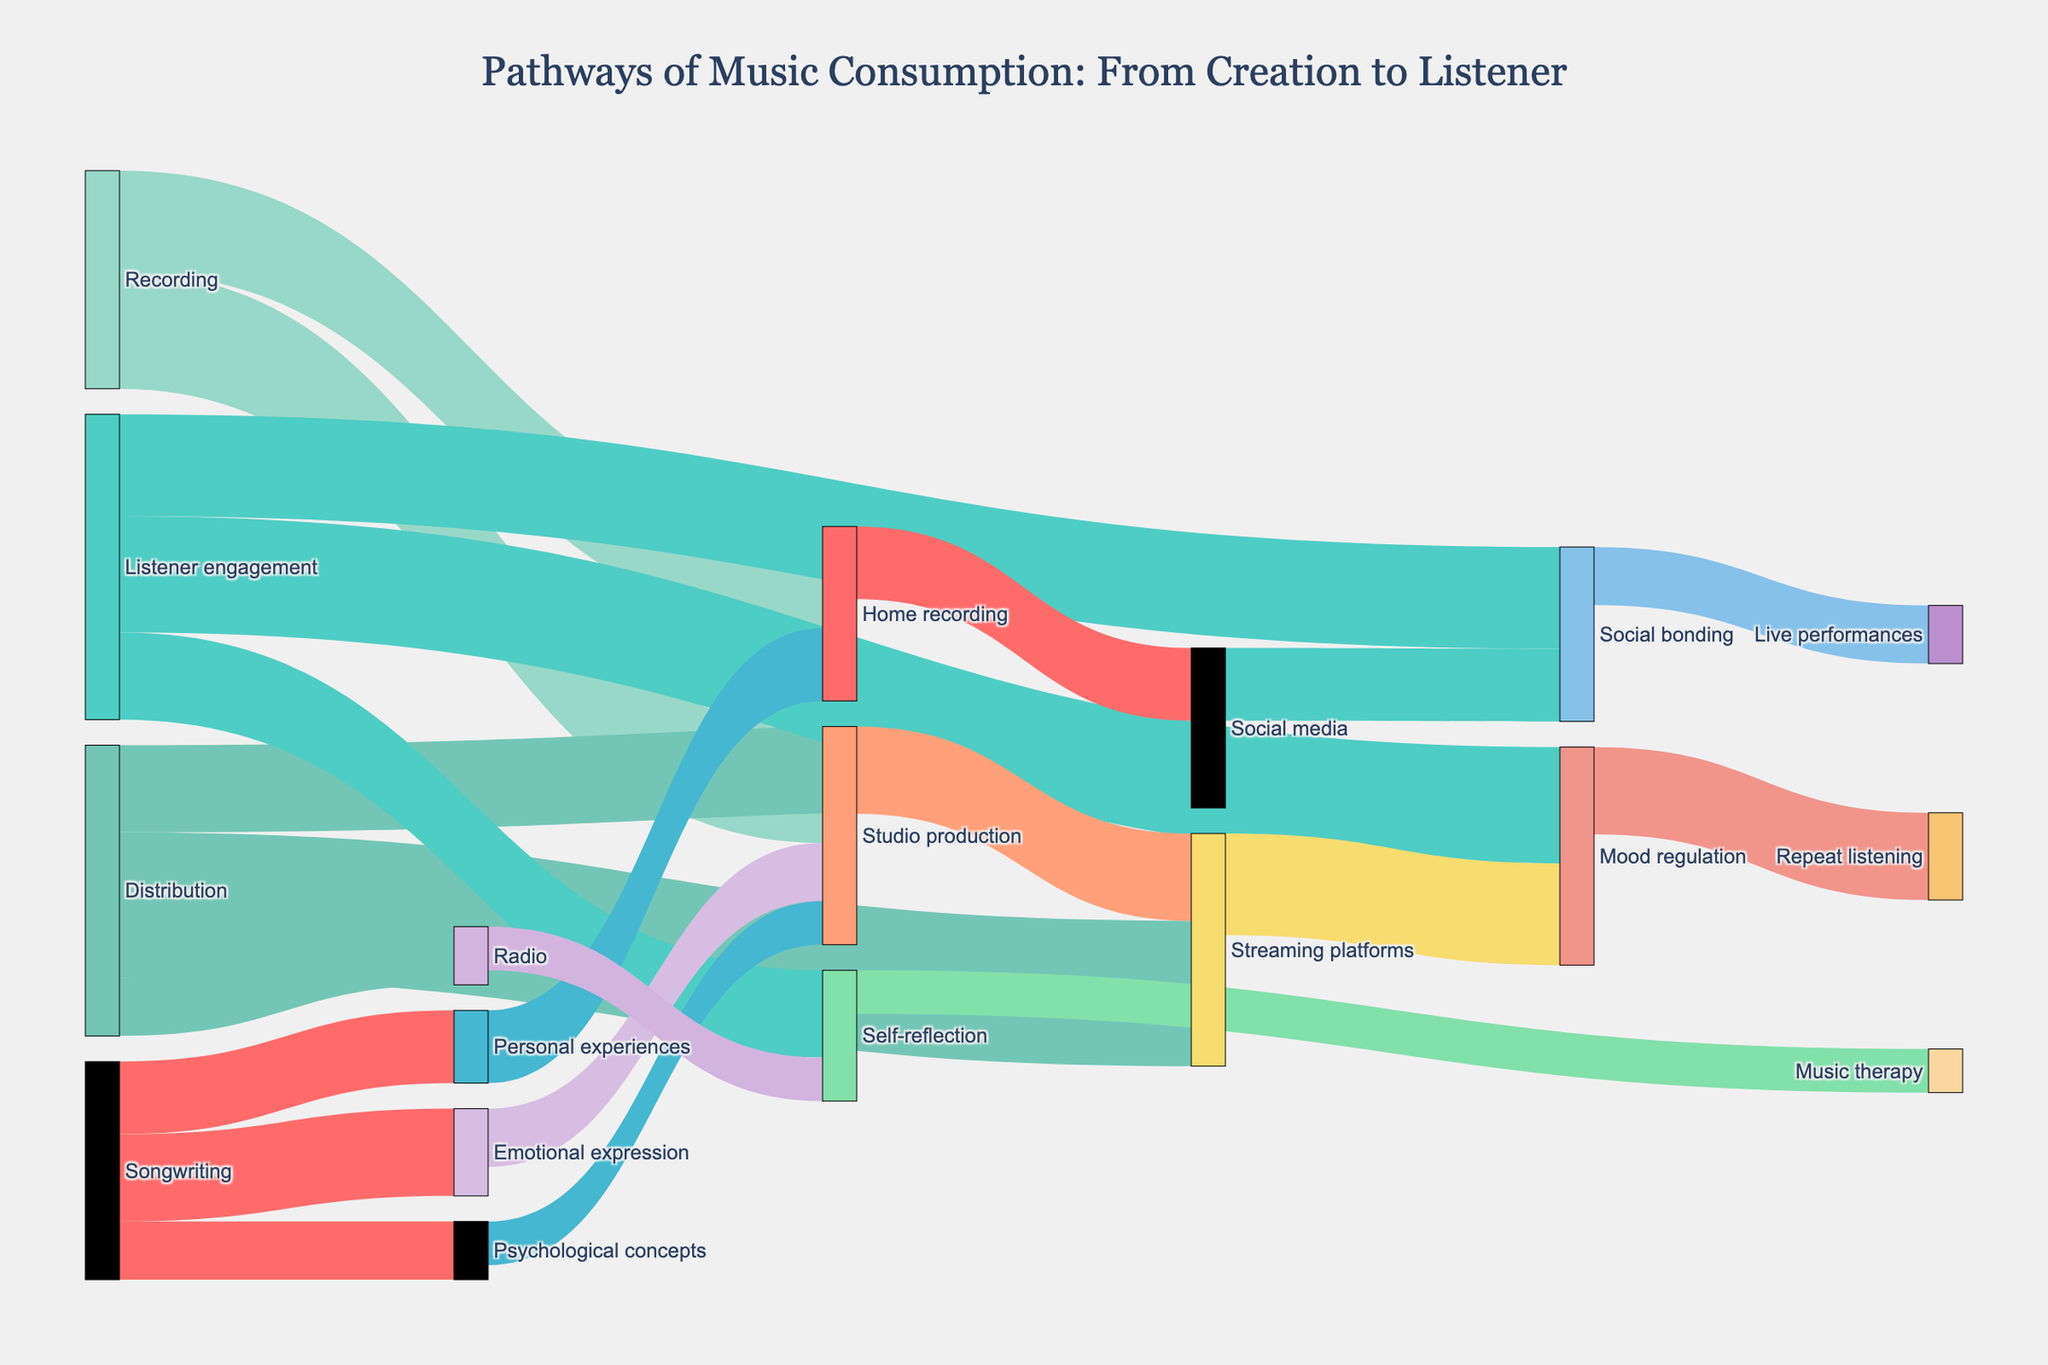What are the main pathways from Songwriting to Recording? The pathways from Songwriting to Recording include transitions through "Emotional expression" to "Studio production," "Personal experiences" to "Home recording," and "Psychological concepts" to "Studio production." These connect the initial stages of songwriting with methods of recording the music.
Answer: Emotional expression to Studio production, Personal experiences to Home recording, Psychological concepts to Studio production What is the total value of music distributed through Streaming platforms? To get the total value of music distributed through Streaming platforms, consider the value coming from "Studio production" which is 30. Therefore, the total value is the sum of these connections.
Answer: 30 Which factor has the highest listener engagement value? Look at the values associated with listener engagement factors: "Mood regulation" (40), "Social bonding" (35), and "Self-reflection" (30). The highest value is 40 for "Mood regulation."
Answer: Mood regulation How many unique paths connect from Songwriting to Listener engagement? Calculate the unique paths starting from any Songwriting source to any Listener engagement target. Paths include: "Songwriting -> Emotional expression -> Studio production -> Streaming platforms -> Mood regulation," "Songwriting -> Personal experiences -> Home recording -> Social media -> Social bonding," etc. There are a total of six unique paths.
Answer: 6 Compare the values connecting Recording to its targets. Which path has the highest value and what is that value? Look at the values for each target from Recording. The values are "Studio production" (40) and "Home recording" (35). The highest value is 40 for "Studio production."
Answer: Studio production with 40 What is the total value of Listener engagement derived from Distribution channels? Summing up the values of paths from "Streaming platforms" to "Mood regulation" (35), "Social media" to "Social bonding" (25), and "Radio" to "Self-reflection" (15) gives 35 + 25 + 15. The total value is 75.
Answer: 75 What is the smallest value in the diagram, and which paths does it correspond to? The smallest value visible in the diagram is 15. It corresponds to the paths "Songwriting -> Psychological concepts" and "Psychological concepts -> Studio production," "Radio -> Self-reflection," and "Personal experiences -> Home recording."
Answer: 15; Songwriting -> Psychological concepts, Psychological concepts -> Studio production, Radio -> Self-reflection Which Distribution channel carries the most value to Listener engagement and through which pathways? Summarize the Listener engagement values from each Distribution channel. "Streaming platforms" leads to Pathways “Mood regulation” (35). This is the highest among the Distribution channels leading to Listener engagement factors.
Answer: Streaming platforms through Mood regulation 